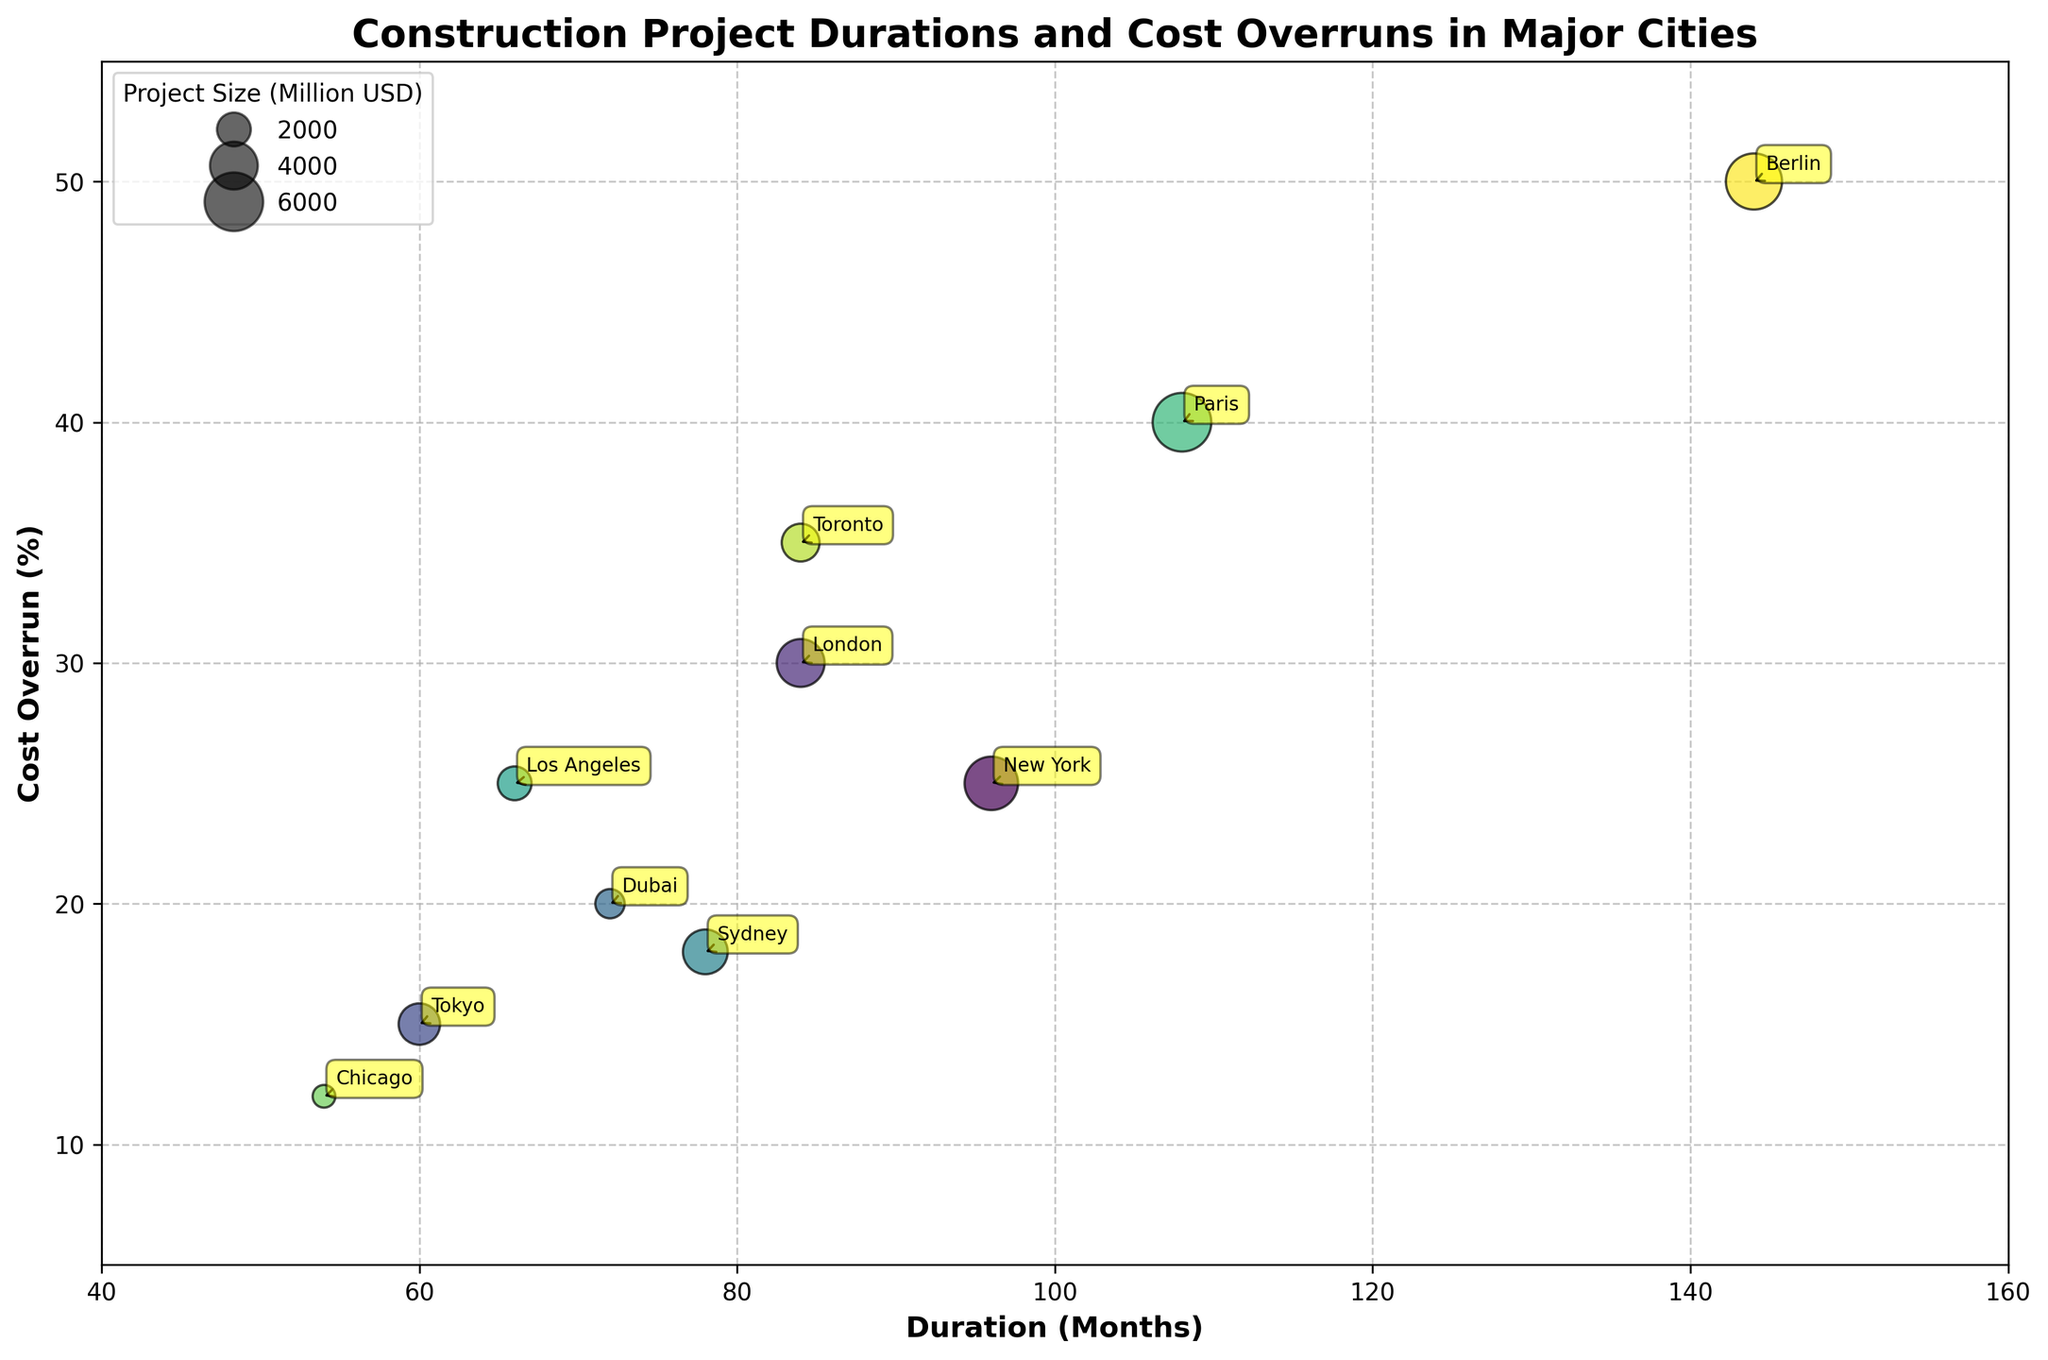How many projects have a cost overrun percentage greater than 20%? By observing the y-axis and identifying the dots with a cost overrun percentage greater than 20%, we see there are six projects: Grand Paris Express, BER Airport Terminal, Eglinton Crosstown LRT, Thames Tideway Tunnel, LAX Automated People Mover, and Second Avenue Subway Phase 1.
Answer: Six Which project took the longest duration? By looking at the x-axis (Duration in Months) and finding the project with the maximum value, the BER Airport Terminal stands out with 144 months.
Answer: BER Airport Terminal What's the relationship between the project size and the bubble size? The bubble size is proportional to the project size in Million USD. Larger projects have larger bubble sizes, such as Grand Paris Express and BER Airport Terminal, whereas smaller projects like the Chicago Riverwalk have smaller bubbles.
Answer: Proportional Are there any projects with both a high cost overrun (above 30%) and a long duration (above 80 months)? By looking at the upper right quadrant of the scatter plot, we identify three projects: Grand Paris Express, BER Airport Terminal, and Eglinton Crosstown LRT.
Answer: Three Which city has the lowest cost overrun percentage? Observing the y-axis and finding the lowest point, the Chicago Riverwalk in Chicago has the lowest cost overrun percentage of 12%.
Answer: Chicago What is the duration and cost overrun for the Burj Khalifa project? Find the Burj Khalifa project in the scatter plot, then read its positions on the x-axis (Duration) and y-axis (Cost Overrun), which are 72 months and 20% respectively.
Answer: 72 months, 20% Which project has the highest cost overrun percentage? Find the highest point on the y-axis, which corresponds to the BER Airport Terminal with a cost overrun percentage of 50%.
Answer: BER Airport Terminal In terms of the project size, which is bigger: Thames Tideway Tunnel or Sydney Metro Northwest? By comparing the bubble sizes for these two projects, Thames Tideway Tunnel has a larger bubble size (4000 million USD) than Sydney Metro Northwest (3500 million USD).
Answer: Thames Tideway Tunnel Is there a positive correlation between project duration and cost overrun percentage? By visually examining the trend of the scatter plot, it can be observed that projects with longer durations tend to also have higher cost overruns, suggesting a positive correlation.
Answer: Yes 